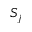<formula> <loc_0><loc_0><loc_500><loc_500>S _ { j }</formula> 